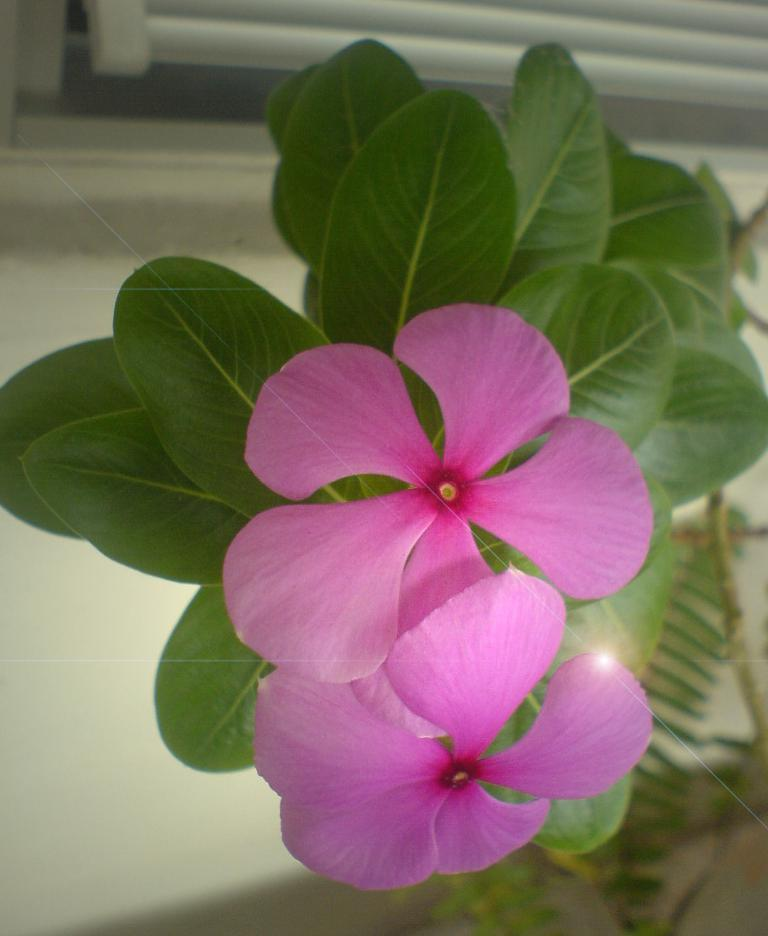What type of flowers can be seen on the plant in the image? There are two pink flowers on a plant in the image. Can you describe the background of the image? There is a window visible in the background of the image. What type of cream is being used by the writer in the image? There is no writer or cream present in the image; it only features two pink flowers on a plant and a window in the background. 